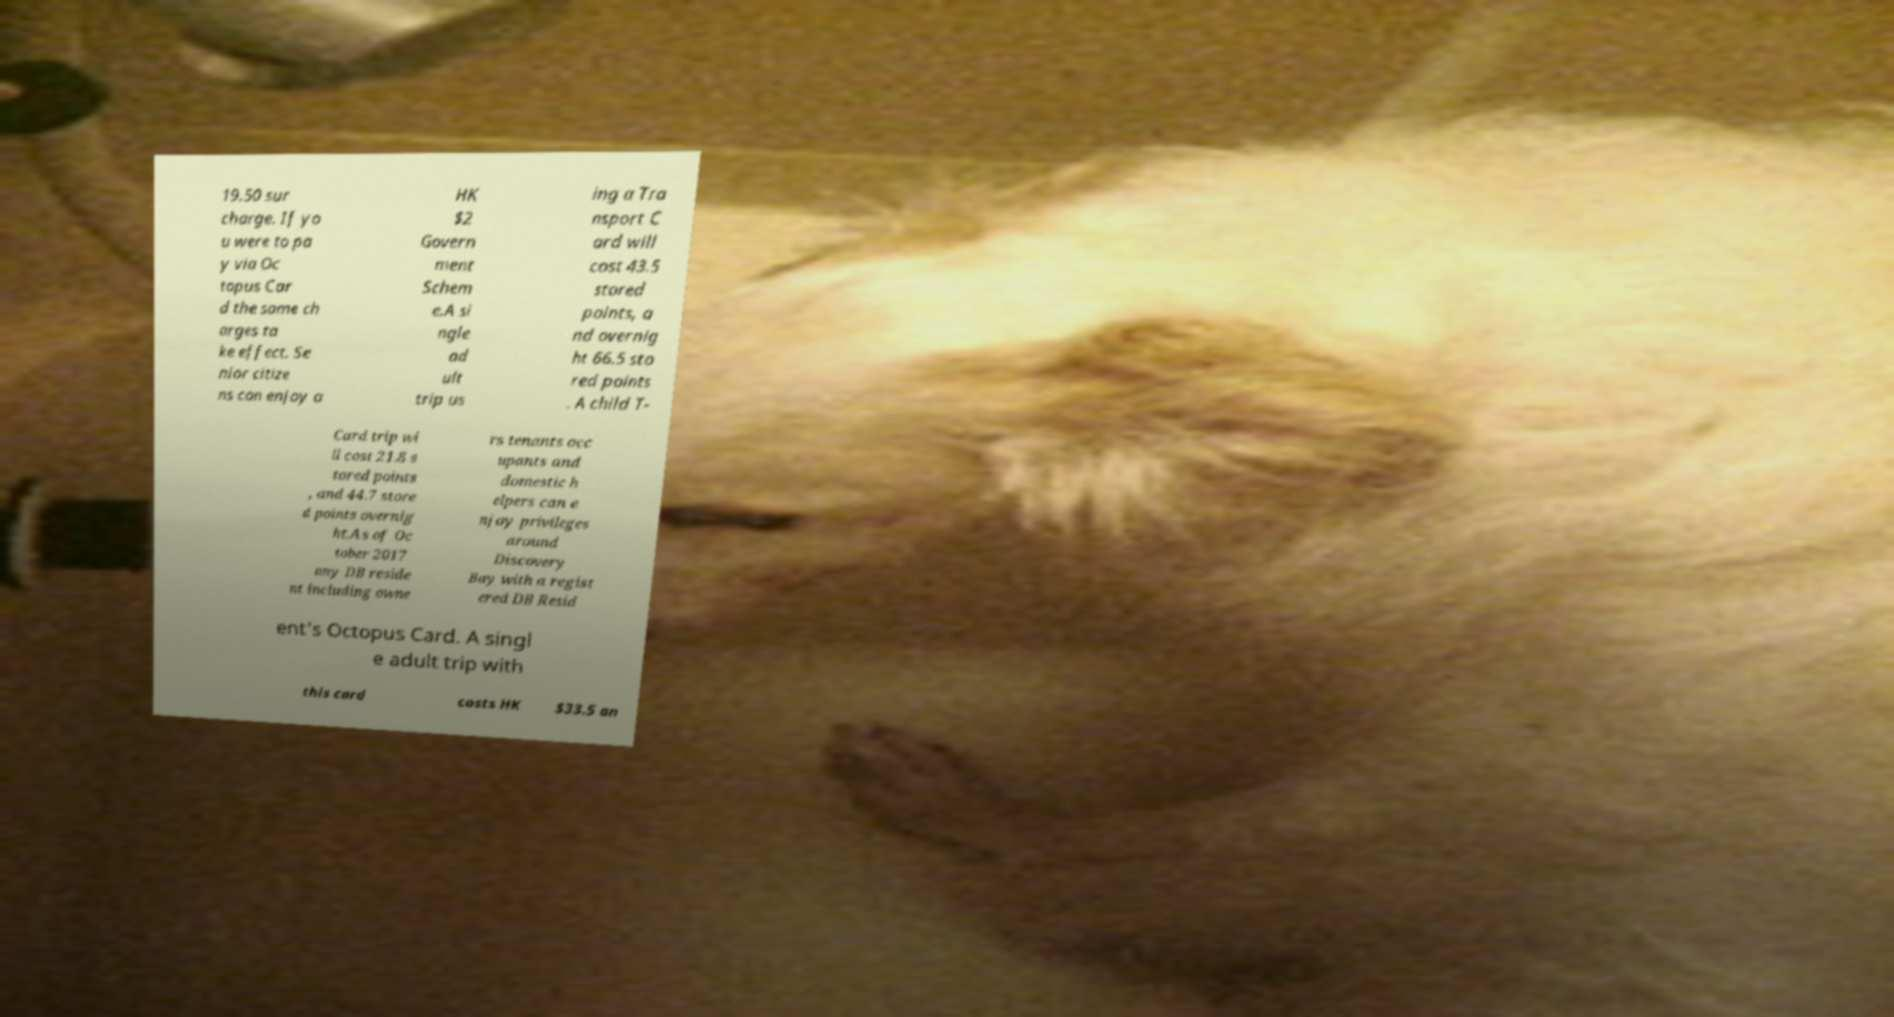There's text embedded in this image that I need extracted. Can you transcribe it verbatim? 19.50 sur charge. If yo u were to pa y via Oc topus Car d the same ch arges ta ke effect. Se nior citize ns can enjoy a HK $2 Govern ment Schem e.A si ngle ad ult trip us ing a Tra nsport C ard will cost 43.5 stored points, a nd overnig ht 66.5 sto red points . A child T- Card trip wi ll cost 21.8 s tored points , and 44.7 store d points overnig ht.As of Oc tober 2017 any DB reside nt including owne rs tenants occ upants and domestic h elpers can e njoy privileges around Discovery Bay with a regist ered DB Resid ent's Octopus Card. A singl e adult trip with this card costs HK $33.5 an 